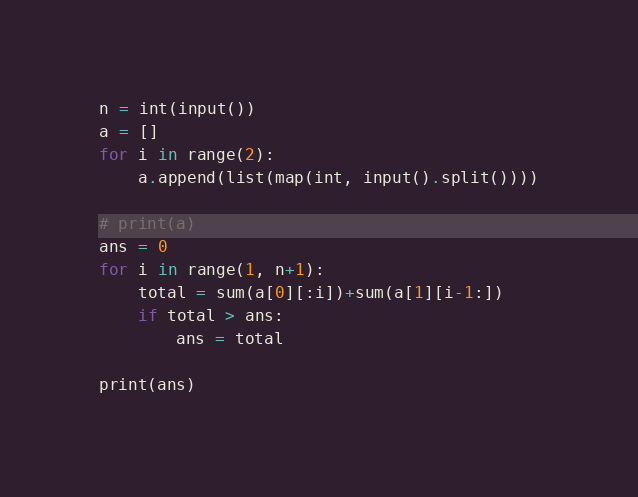Convert code to text. <code><loc_0><loc_0><loc_500><loc_500><_Python_>n = int(input())
a = []
for i in range(2):
    a.append(list(map(int, input().split())))

# print(a)
ans = 0
for i in range(1, n+1):
    total = sum(a[0][:i])+sum(a[1][i-1:])
    if total > ans:
        ans = total

print(ans)
</code> 